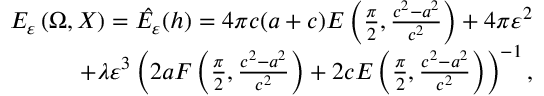Convert formula to latex. <formula><loc_0><loc_0><loc_500><loc_500>\begin{array} { r } { E _ { \varepsilon } \left ( \Omega , X \right ) = \hat { E _ { \varepsilon } } ( h ) = 4 \pi c ( a + c ) E \left ( \frac { \pi } { 2 } , { \frac { c ^ { 2 } - a ^ { 2 } } { c ^ { 2 } } } \right ) + 4 \pi \varepsilon ^ { 2 } } \\ { + \lambda \varepsilon ^ { 3 } \left ( 2 a F \left ( \frac { \pi } { 2 } , \frac { c ^ { 2 } - a ^ { 2 } } { c ^ { 2 } } \right ) + 2 c E \left ( \frac { \pi } { 2 } , \frac { c ^ { 2 } - a ^ { 2 } } { c ^ { 2 } } \right ) \right ) ^ { - 1 } , } \end{array}</formula> 